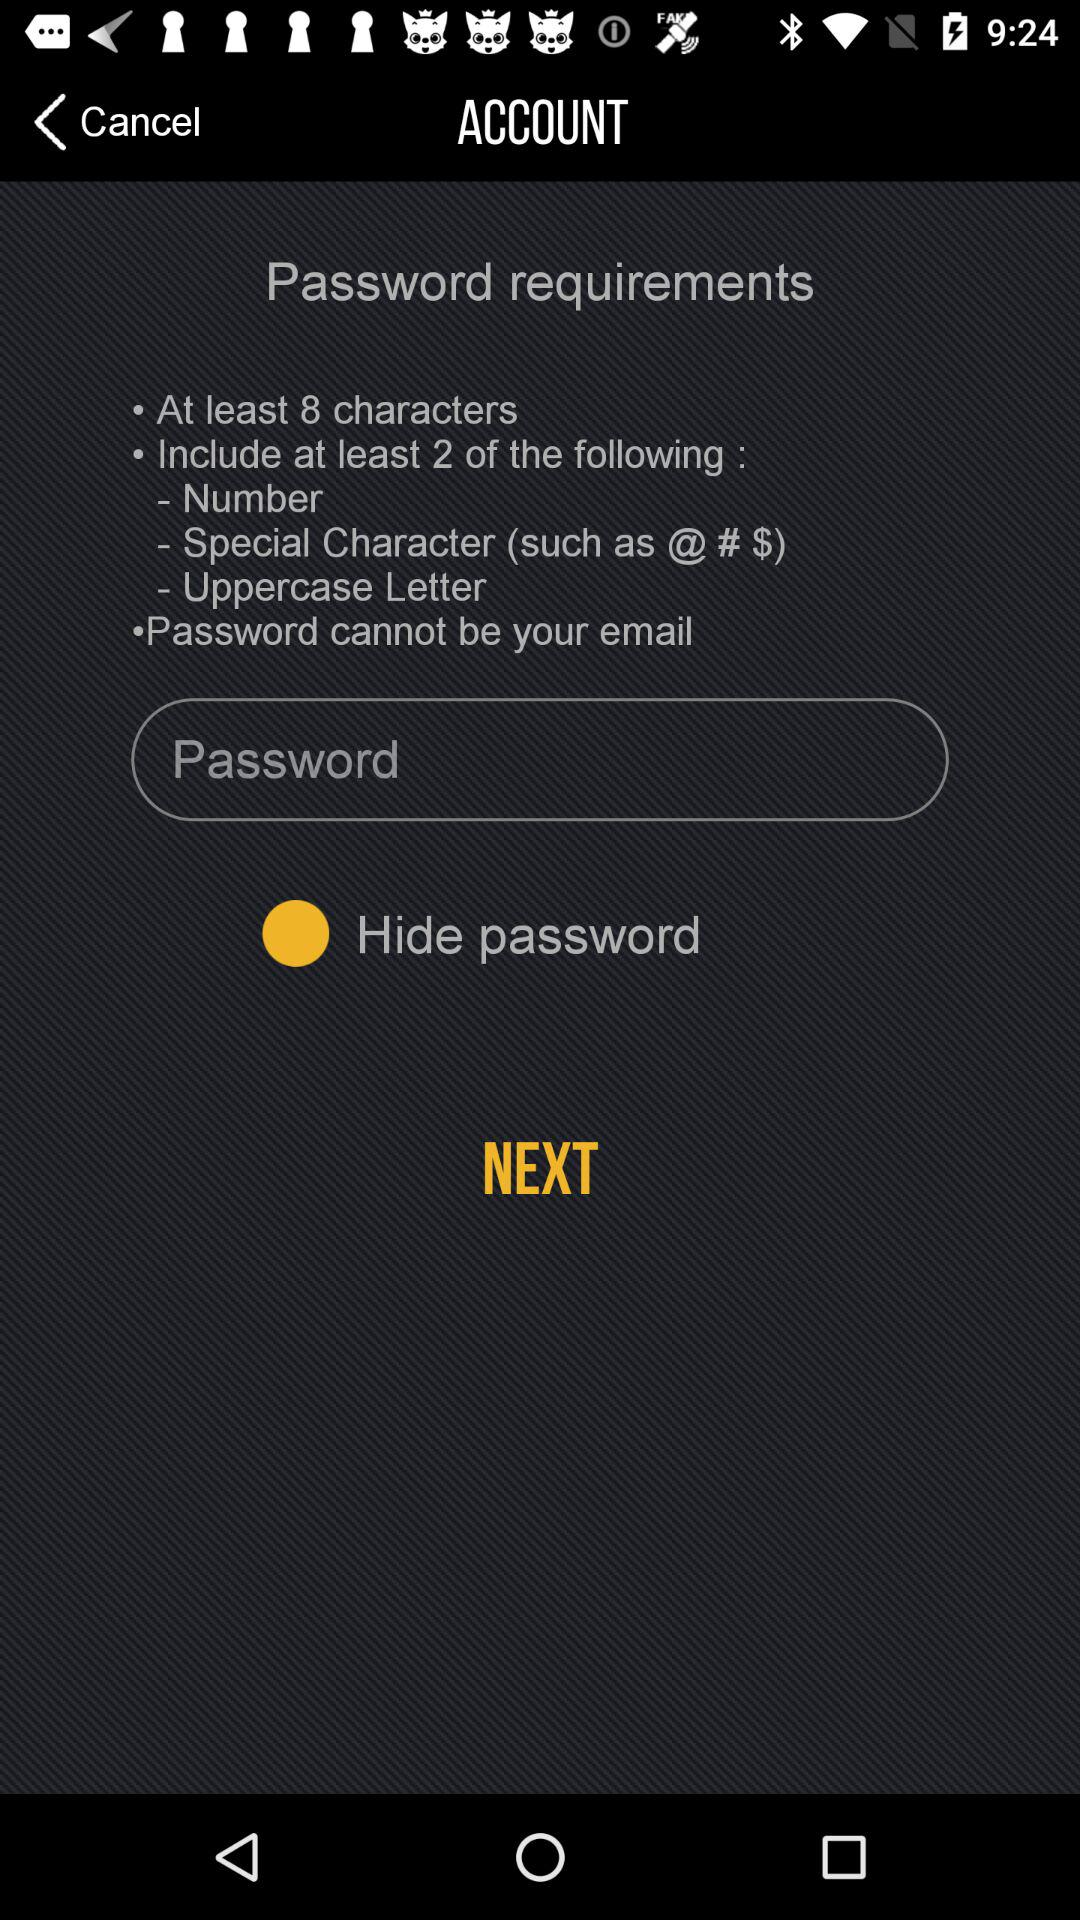What should contain a password? The password should contain: "At least 8 characters", "Include at least 2 of the following : Number, Special Character (such as @ # $), Uppercase Letter" and "Password cannot be your email". 